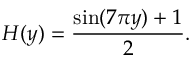Convert formula to latex. <formula><loc_0><loc_0><loc_500><loc_500>H ( y ) = \frac { \sin ( 7 \pi y ) + 1 } { 2 } .</formula> 